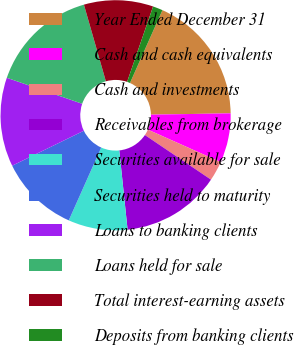Convert chart to OTSL. <chart><loc_0><loc_0><loc_500><loc_500><pie_chart><fcel>Year Ended December 31<fcel>Cash and cash equivalents<fcel>Cash and investments<fcel>Receivables from brokerage<fcel>Securities available for sale<fcel>Securities held to maturity<fcel>Loans to banking clients<fcel>Loans held for sale<fcel>Total interest-earning assets<fcel>Deposits from banking clients<nl><fcel>18.06%<fcel>6.94%<fcel>2.78%<fcel>13.89%<fcel>8.33%<fcel>11.11%<fcel>12.5%<fcel>15.28%<fcel>9.72%<fcel>1.39%<nl></chart> 